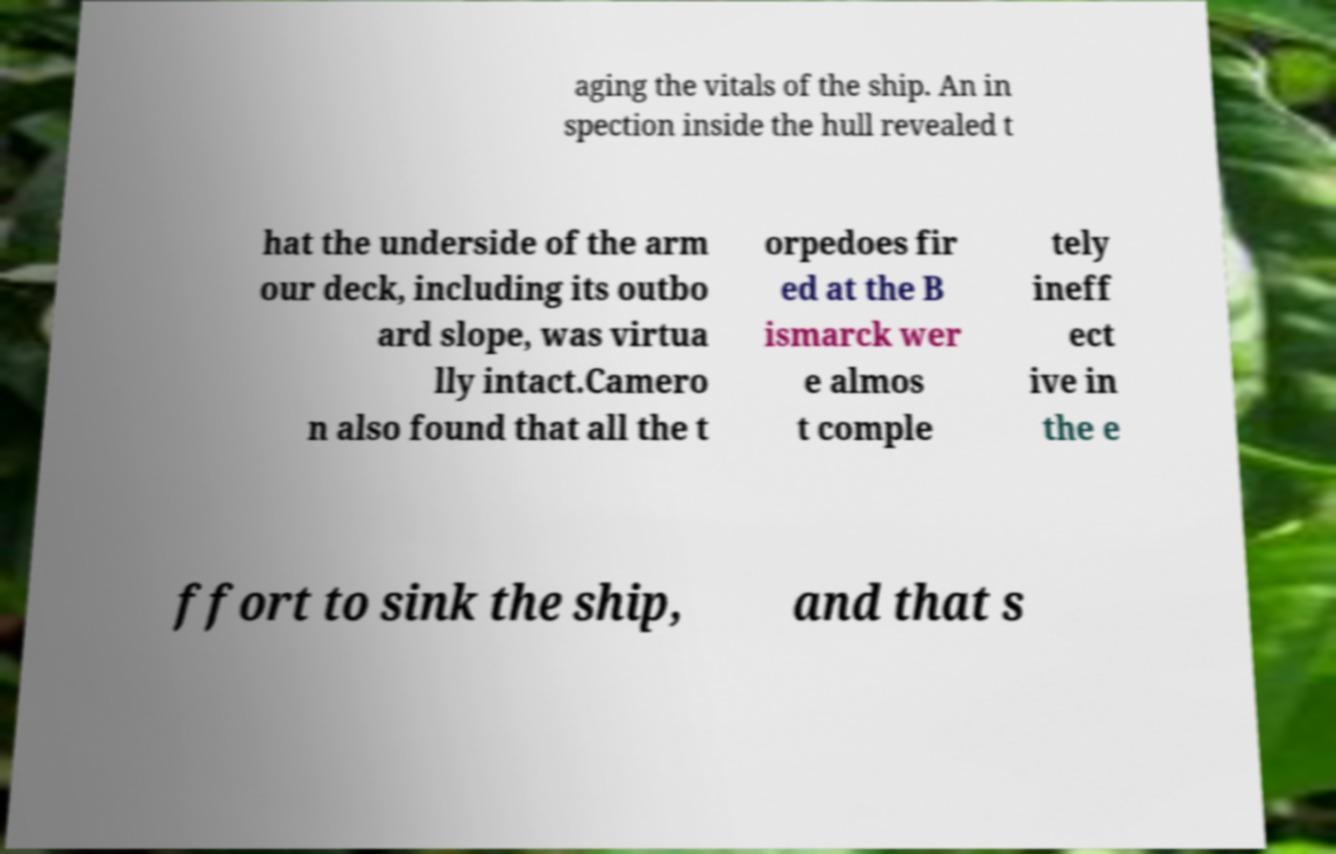Can you accurately transcribe the text from the provided image for me? aging the vitals of the ship. An in spection inside the hull revealed t hat the underside of the arm our deck, including its outbo ard slope, was virtua lly intact.Camero n also found that all the t orpedoes fir ed at the B ismarck wer e almos t comple tely ineff ect ive in the e ffort to sink the ship, and that s 